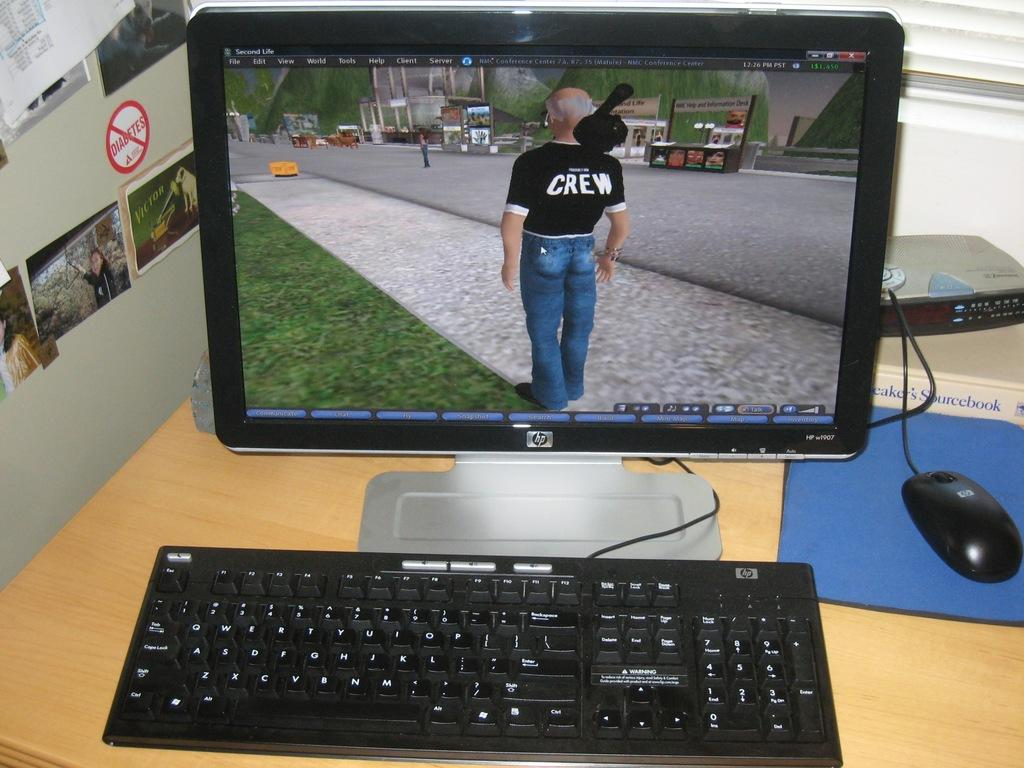What electronic device is on the desk in the image? There is a monitor on the desk in the image. What other items are on the desk that are used for input? There is a keyboard and a mouse on the desk. What can be seen on the wall in the image? There are photo frames on the wall. What is happening outside the window in the image? There is a person standing on the road. What type of substance is being used in the battle depicted in the photo frames? There is no battle depicted in the photo frames, and therefore no substance being used. How many houses are visible in the image? There are no houses visible in the image. 